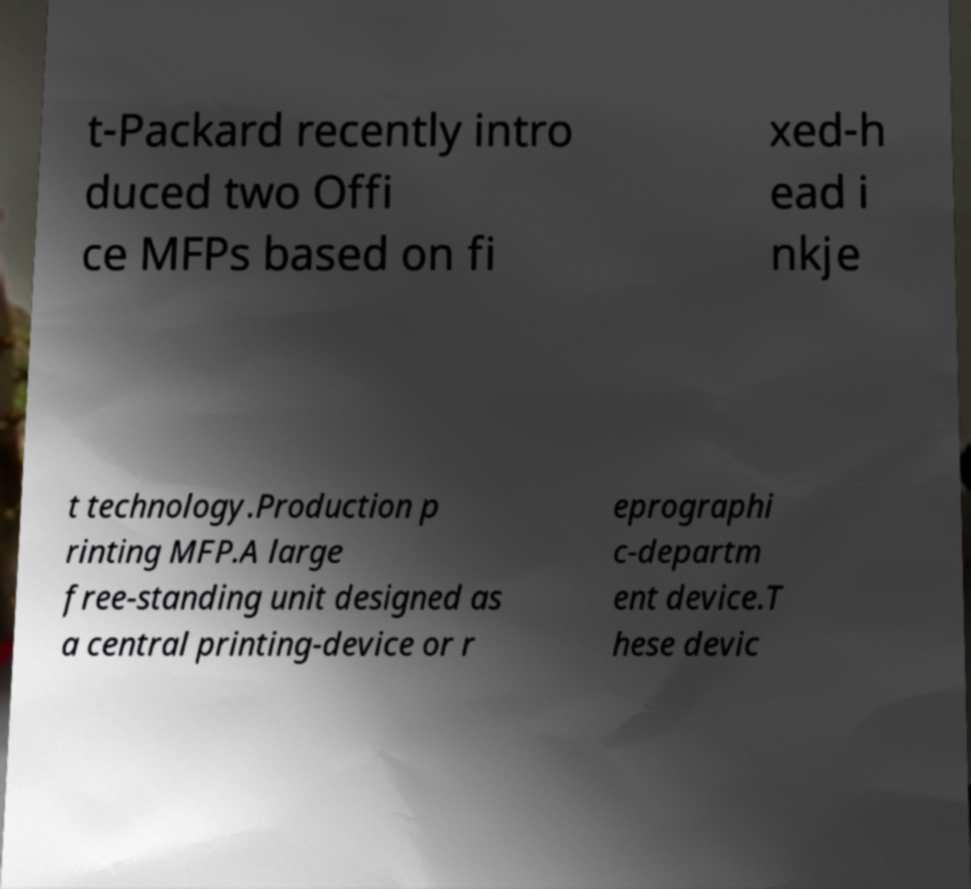Can you read and provide the text displayed in the image?This photo seems to have some interesting text. Can you extract and type it out for me? t-Packard recently intro duced two Offi ce MFPs based on fi xed-h ead i nkje t technology.Production p rinting MFP.A large free-standing unit designed as a central printing-device or r eprographi c-departm ent device.T hese devic 